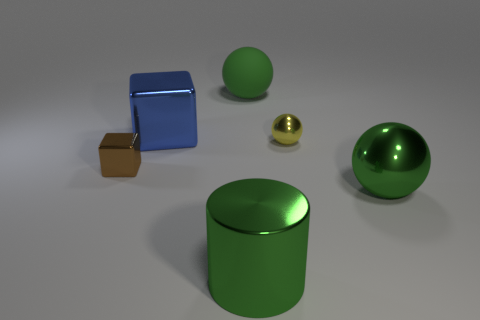There is a sphere that is the same color as the big matte thing; what is its material?
Offer a terse response. Metal. Are there fewer green cylinders than red metallic cubes?
Give a very brief answer. No. Is the size of the yellow metal sphere the same as the green metal thing that is behind the green metal cylinder?
Offer a terse response. No. The tiny thing in front of the tiny metallic thing right of the cylinder is what color?
Provide a short and direct response. Brown. How many objects are either big things to the left of the green shiny cylinder or large green metal things on the right side of the brown block?
Your answer should be compact. 3. Is the yellow metal object the same size as the brown metal object?
Your response must be concise. Yes. Is there any other thing that has the same size as the yellow sphere?
Provide a short and direct response. Yes. There is a small shiny object that is behind the small brown thing; is its shape the same as the large green thing that is to the right of the yellow shiny object?
Keep it short and to the point. Yes. What is the size of the green metallic ball?
Your answer should be compact. Large. There is a tiny object to the left of the big object on the left side of the big green metal thing that is left of the yellow shiny ball; what is its material?
Keep it short and to the point. Metal. 